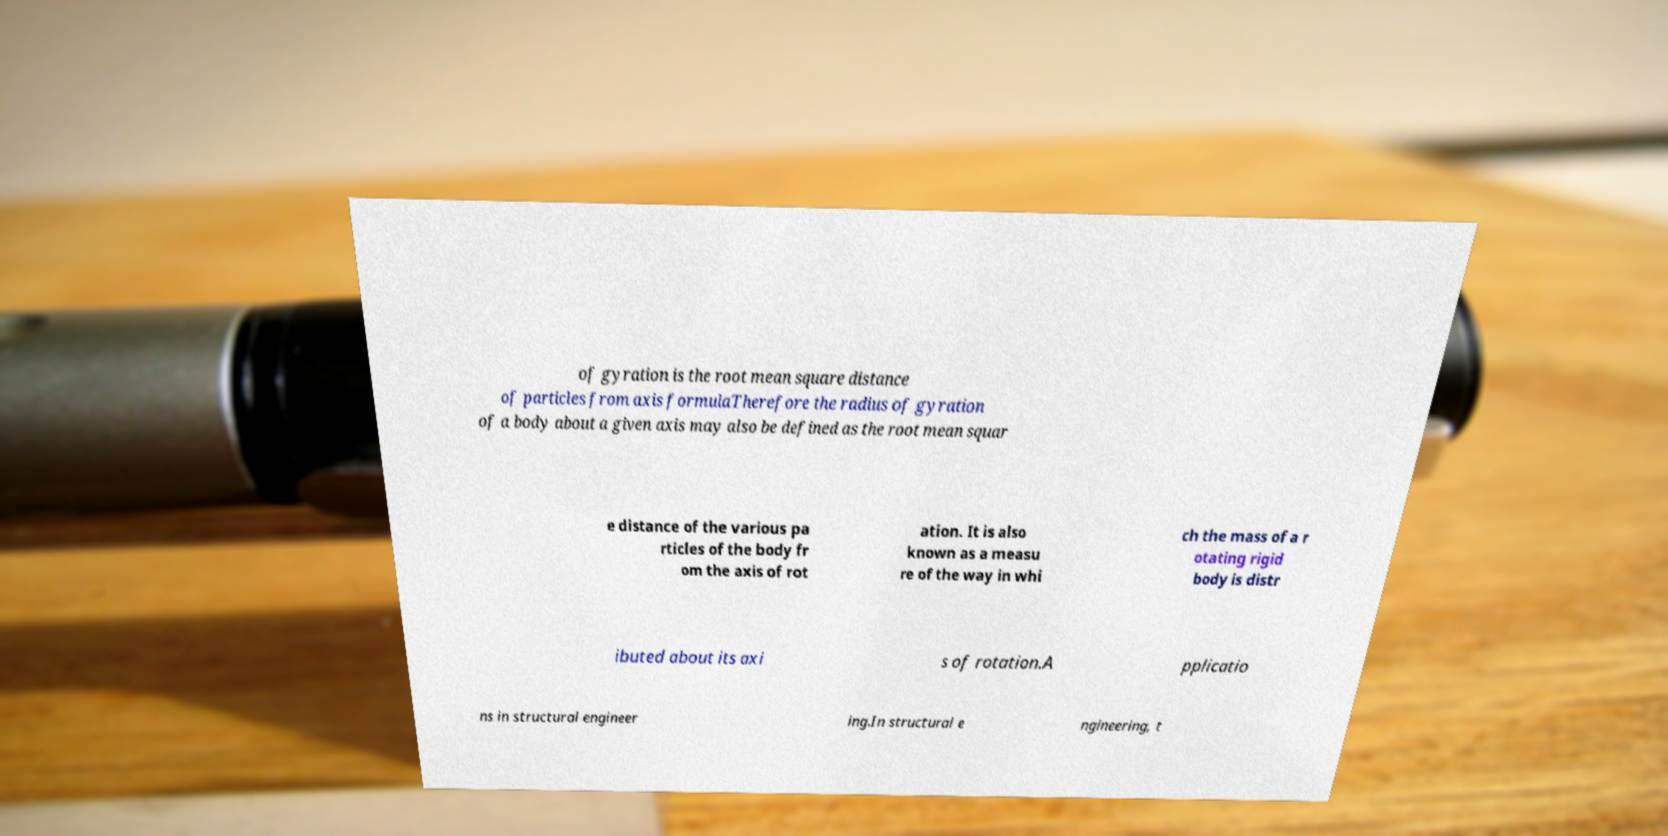I need the written content from this picture converted into text. Can you do that? of gyration is the root mean square distance of particles from axis formulaTherefore the radius of gyration of a body about a given axis may also be defined as the root mean squar e distance of the various pa rticles of the body fr om the axis of rot ation. It is also known as a measu re of the way in whi ch the mass of a r otating rigid body is distr ibuted about its axi s of rotation.A pplicatio ns in structural engineer ing.In structural e ngineering, t 